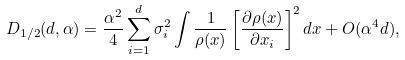Convert formula to latex. <formula><loc_0><loc_0><loc_500><loc_500>D _ { 1 / 2 } ( d , \alpha ) = \frac { \alpha ^ { 2 } } { 4 } \sum _ { i = 1 } ^ { d } \sigma _ { i } ^ { 2 } \int \frac { 1 } { \rho ( x ) } \left [ \frac { \partial \rho ( x ) } { \partial x _ { i } } \right ] ^ { 2 } d x + O ( \alpha ^ { 4 } d ) ,</formula> 